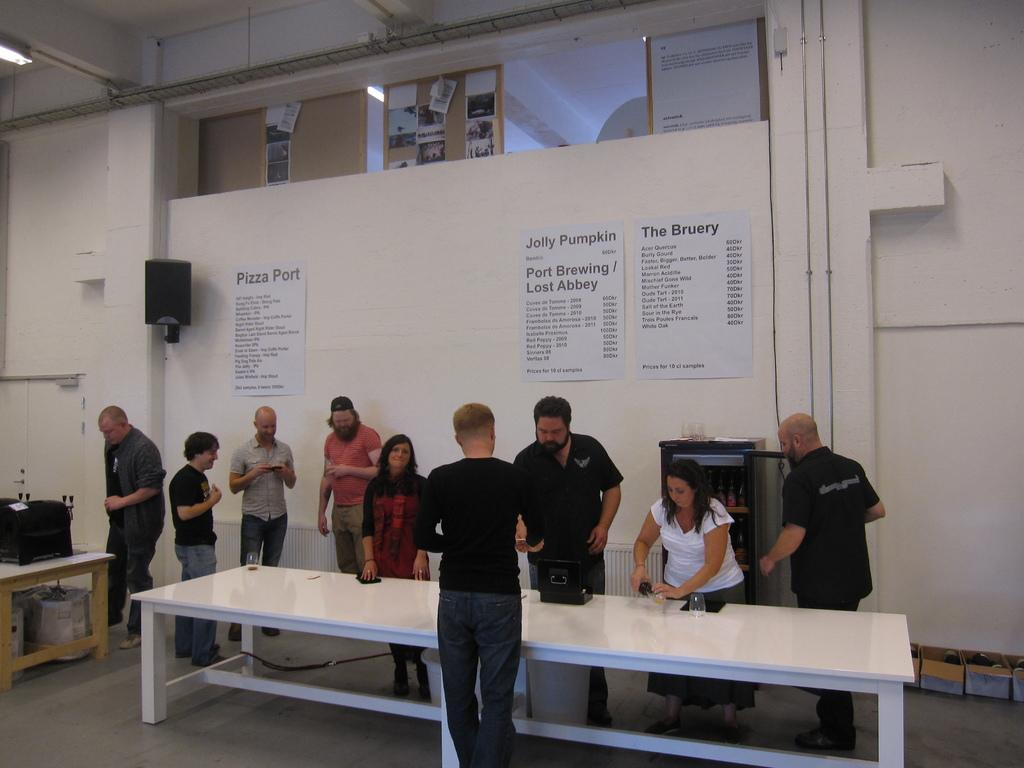How many people are in the image? There is a group of people in the image. What can be seen on a table in the background? There are glasses on a table in the background. What is attached to the wall in the background? There are papers attached to a wall in the background. What type of audio equipment is visible in the background? There is a woofer in the background. Is there a girl celebrating her birthday in the image? There is no information about a girl or a birthday celebration in the image. 